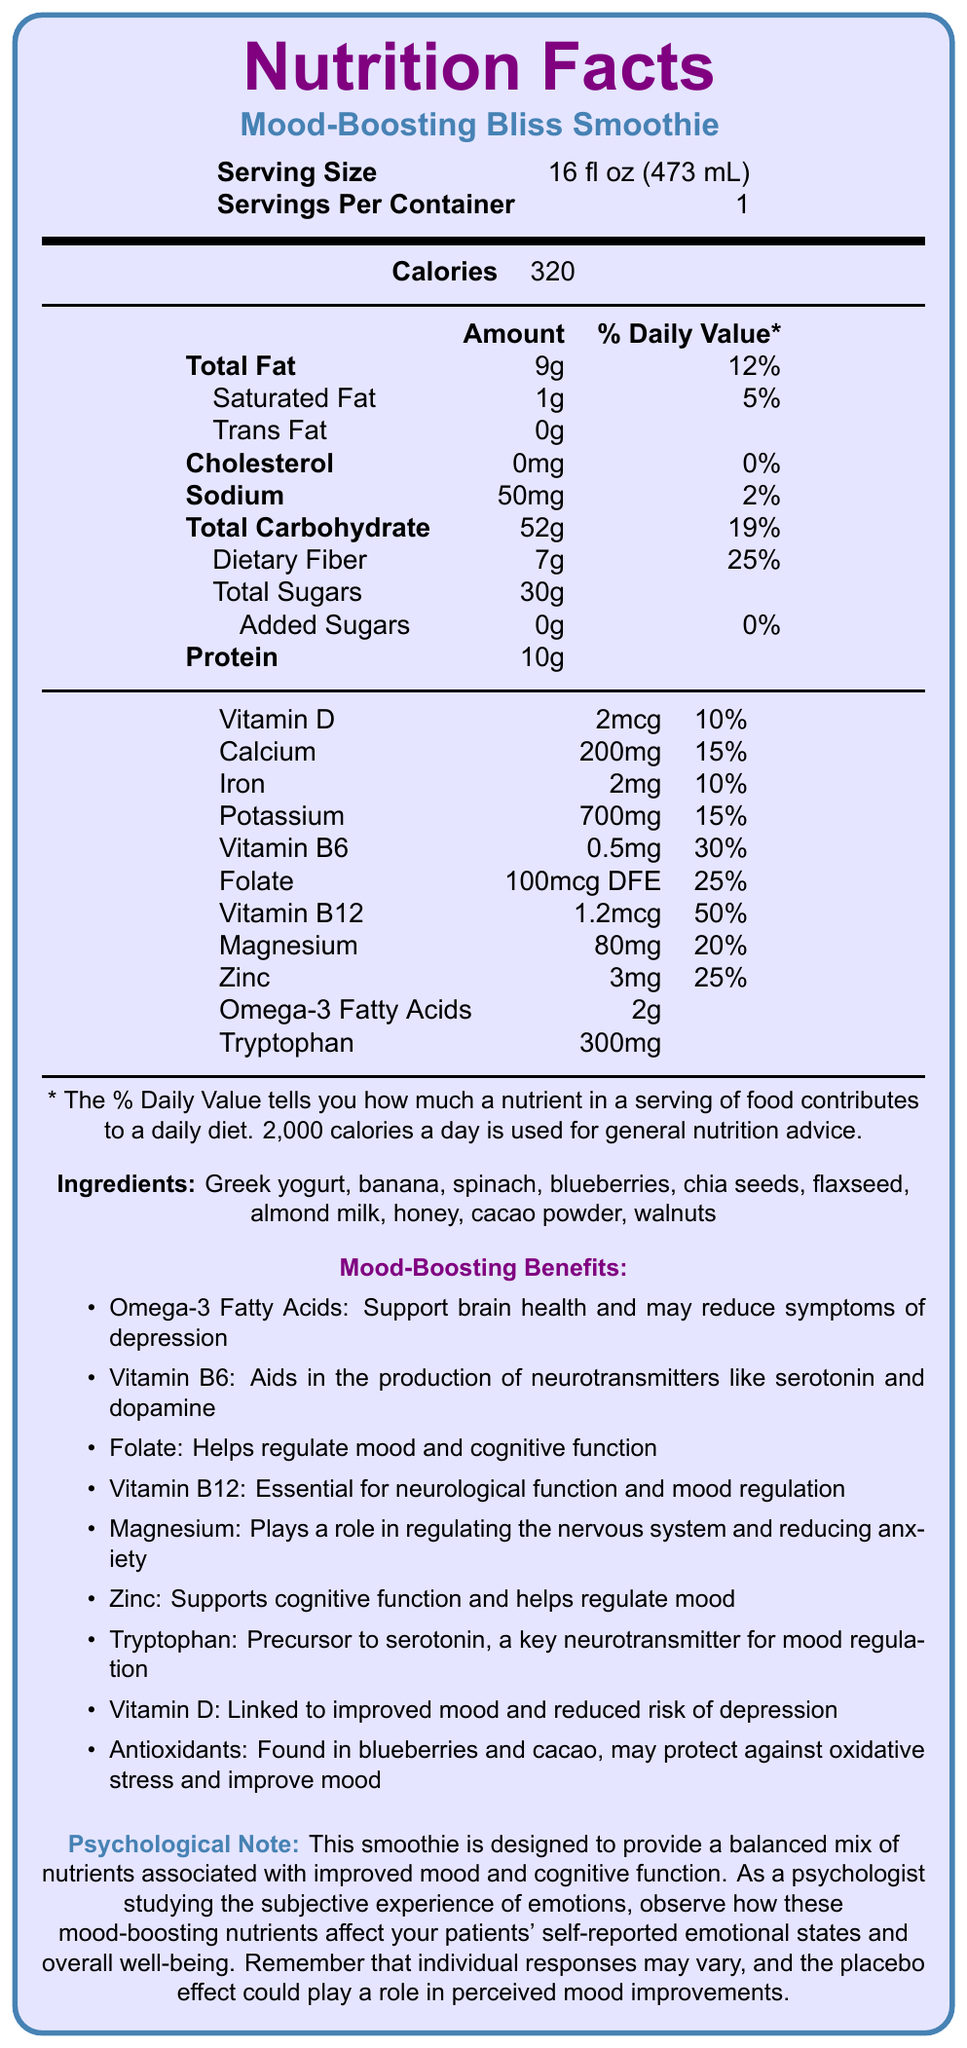what is the serving size of the Mood-Boosting Bliss Smoothie? The serving size is explicitly stated in the document under the "Serving Size" label.
Answer: 16 fl oz (473 mL) how many calories are in one serving of the smoothie? The calorie content is listed under the "Calories" section in the document.
Answer: 320 what is the percentage daily value of Vitamin B6 in one serving? The percentage daily value for Vitamin B6 is listed under the "Vitamin B6" section.
Answer: 30% how much protein does one serving of the smoothie contain? The document specifies the protein content in the "Protein" section.
Answer: 10g what are two key ingredients in the Mood-Boosting Bliss Smoothie that are high in antioxidants? The section on ingredients and the mood-boosting benefits lists these ingredients as sources of antioxidants.
Answer: Blueberries and cacao powder which of these is a mood-boosting benefit mentioned in the document? A. Decreased cholesterol levels B. Improved skin health C. Helps regulate mood and cognitive function The mood-boosting benefits specifically mention that folate helps regulate mood and cognitive function.
Answer: C how many grams of total sugars are in one serving? A. 25g B. 30g C. 15g The document states that the total sugars amount is 30g.
Answer: B are there any added sugars in the smoothie? The document clearly mentions that the amount of added sugars is 0g.
Answer: No is the Mood-Boosting Bliss Smoothie designed to improve mood and cognitive function? The psychological note at the end of the document confirms that the smoothie is designed for this purpose.
Answer: Yes Summarize the main nutritional benefits of the Mood-Boosting Bliss Smoothie for emotional well-being. The document lists several nutrients and their specific mood-boosting benefits, along with a psychological note emphasizing the intended emotional and cognitive benefits.
Answer: The Mood-Boosting Bliss Smoothie contains a blend of nutrients such as omega-3 fatty acids, various B vitamins, magnesium, and tryptophan, which support brain health, neurotransmitter production, and mood regulation. Ingredients like blueberries and cacao provide antioxidants that protect against oxidative stress. Overall, these nutrients are associated with improved mood and cognitive function. what is the psychological effect of consuming antioxidants found in the smoothie? The document mentions that antioxidants may protect against oxidative stress and improve mood, but it doesn't provide detailed information on their direct psychological effects or any study results.
Answer: Cannot be determined which nutrient helps in the production of neurotransmitters like serotonin and dopamine? The document mentions that Vitamin B6 aids in the production of neurotransmitters such as serotonin and dopamine in the mood-boosting benefits section.
Answer: Vitamin B6 does this smoothie have any cholesterol? The document lists the cholesterol amount as 0mg, indicating that it does not contain any cholesterol.
Answer: No what role does magnesium play according to the document? The document states that magnesium plays a role in regulating the nervous system and reducing anxiety in the mood-boosting benefits section.
Answer: Regulating the nervous system and reducing anxiety which ingredient in the smoothie is a precursor to serotonin? The tryptophan content in the smoothie is described as a precursor to serotonin, which is a key neurotransmitter for mood regulation, in the document.
Answer: Tryptophan 